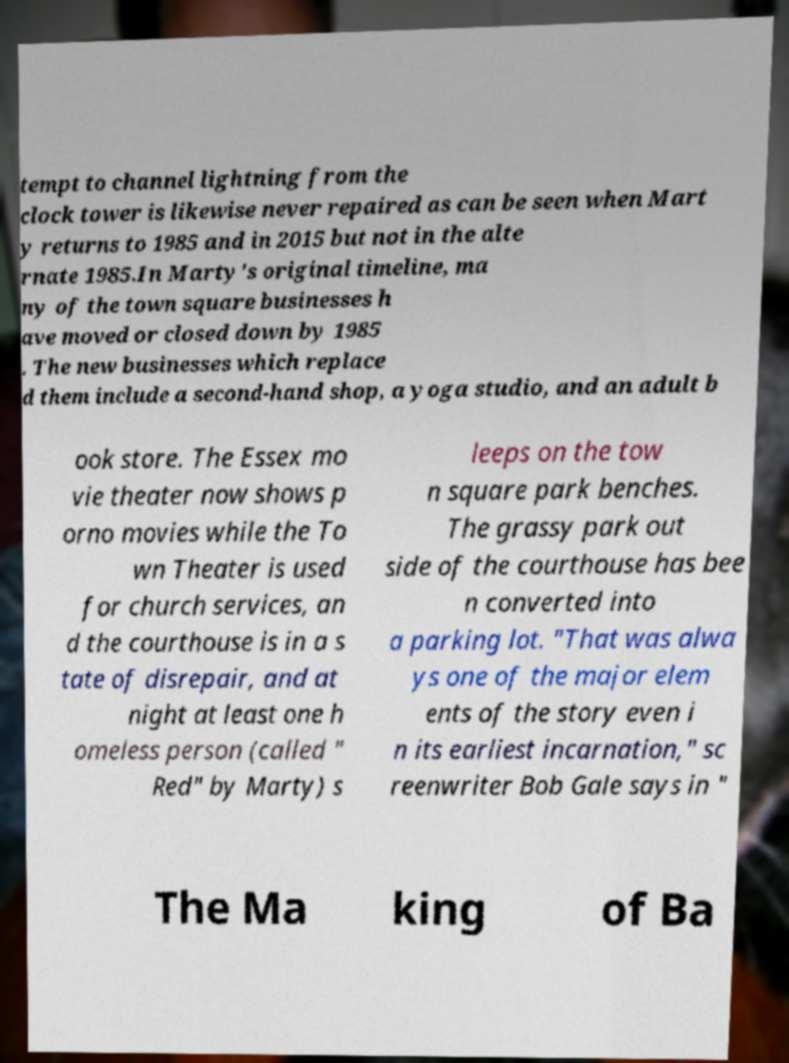Can you read and provide the text displayed in the image?This photo seems to have some interesting text. Can you extract and type it out for me? tempt to channel lightning from the clock tower is likewise never repaired as can be seen when Mart y returns to 1985 and in 2015 but not in the alte rnate 1985.In Marty's original timeline, ma ny of the town square businesses h ave moved or closed down by 1985 . The new businesses which replace d them include a second-hand shop, a yoga studio, and an adult b ook store. The Essex mo vie theater now shows p orno movies while the To wn Theater is used for church services, an d the courthouse is in a s tate of disrepair, and at night at least one h omeless person (called " Red" by Marty) s leeps on the tow n square park benches. The grassy park out side of the courthouse has bee n converted into a parking lot. "That was alwa ys one of the major elem ents of the story even i n its earliest incarnation," sc reenwriter Bob Gale says in " The Ma king of Ba 